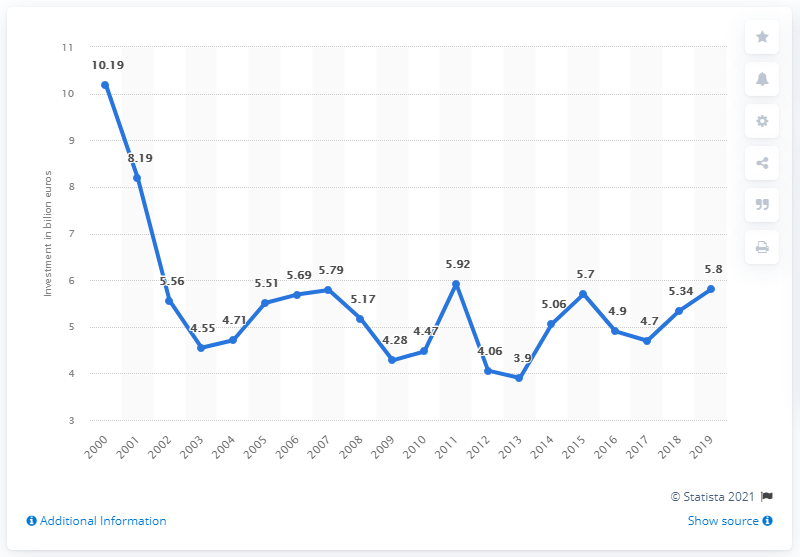Point out several critical features in this image. Spain's investment in the telecommunications industry in 2004 was 4.7 billion dollars. In 2000, the value was the highest among all the years listed. The amount of money invested in the telecommunications industry in 2011 was 4.7 trillion dollars. For how many years has the amount of money available been less than 5 billion euros? 8 years. In 2019, Spain's telecommunications industry received a total investment amount of 5.8 billion US dollars. 